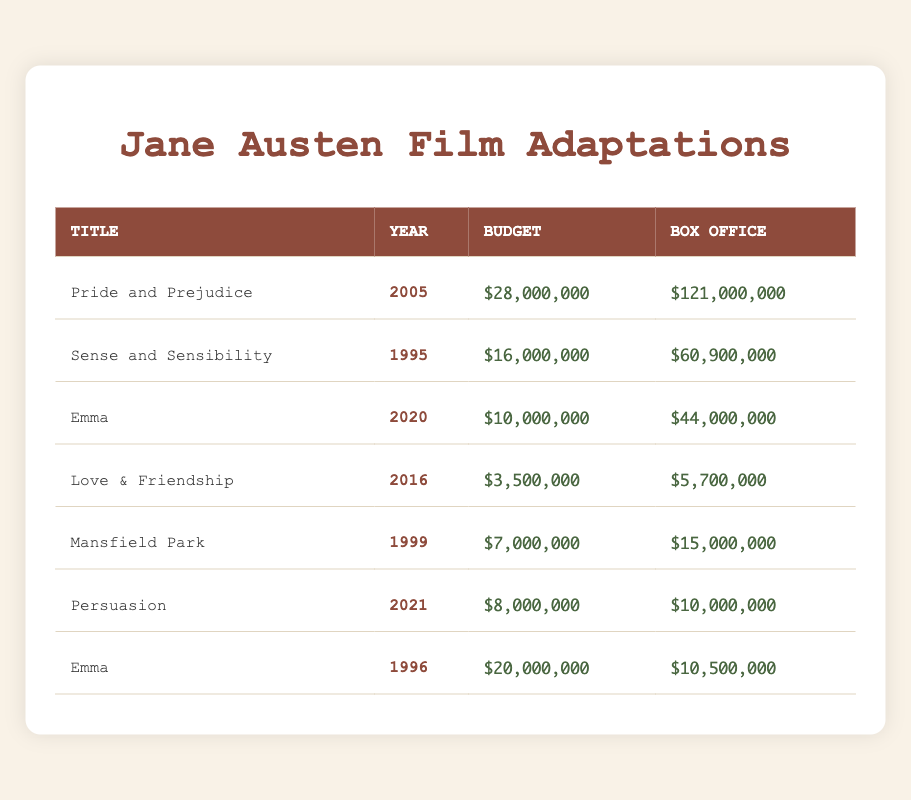What is the budget of "Pride and Prejudice"? The budget for "Pride and Prejudice" can be found in the table under the Budget column for that title, which is $28,000,000.
Answer: $28,000,000 Which adaptation had the highest box office earnings? To find this, I look at the Box Office column in the table. The highest value is $121,000,000 for "Pride and Prejudice."
Answer: "Pride and Prejudice" What is the combined budget of all adaptations from the 1990s? The adaptations from the 1990s are "Sense and Sensibility" ($16,000,000) and "Emma" (1996) ($20,000,000) and "Mansfield Park" ($7,000,000). Adding these gives $16,000,000 + $20,000,000 + $7,000,000 = $43,000,000.
Answer: $43,000,000 Is the budget of "Emma" (2020) more than "Emma" (1996)? The budget of "Emma" (2020) is $10,000,000, and the budget of "Emma" (1996) is $20,000,000. Since $10,000,000 is less than $20,000,000, the statement is false.
Answer: No What is the average box office earnings for all adaptations? I add all the box office earnings: $121,000,000 + $60,900,000 + $44,000,000 + $5,700,000 + $15,000,000 + $10,000,000 + $10,500,000 = $267,100,000. There are seven adaptations, so I divide $267,100,000 by 7, which gives an average of approximately $38,130,000.
Answer: $38,130,000 Which adaptation had the lowest budget and what was that budget? The adaptation with the lowest budget is "Love & Friendship," with a budget of $3,500,000, as seen in the table.
Answer: $3,500,000 Did any film adaptation exceed its budget by more than $100,000 at the box office? To determine this, I check if any box office earnings minus its budget exceed $100,000. For example, "Pride and Prejudice" has a difference of $121,000,000 - $28,000,000 = $93,000,000, and others too. Thus, they all exceed $100,000.
Answer: Yes Which films from the 2000s had a budget of less than $20 million? The films from the 2000s are "Pride and Prejudice" ($28,000,000) and "Emma" (2020) ($10,000,000). "Emma," with a budget of $10,000,000 is the only film under $20 million.
Answer: "Emma" (2020) 